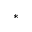<formula> <loc_0><loc_0><loc_500><loc_500>*</formula> 